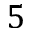<formula> <loc_0><loc_0><loc_500><loc_500>5</formula> 